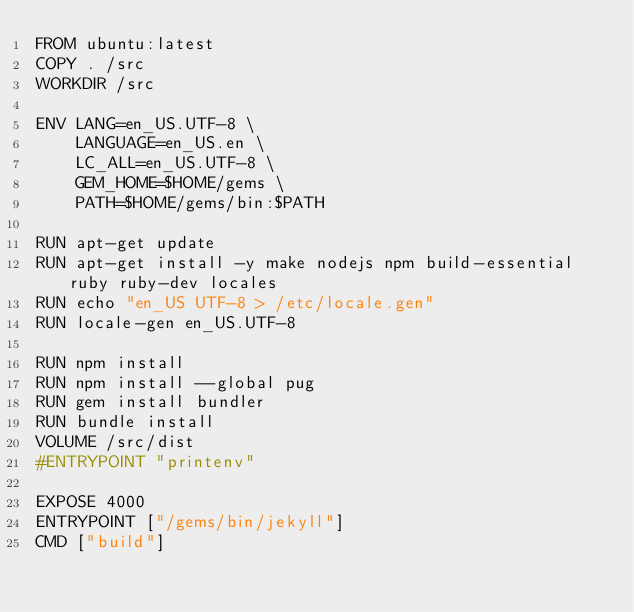Convert code to text. <code><loc_0><loc_0><loc_500><loc_500><_Dockerfile_>FROM ubuntu:latest
COPY . /src
WORKDIR /src

ENV LANG=en_US.UTF-8 \
    LANGUAGE=en_US.en \
    LC_ALL=en_US.UTF-8 \
    GEM_HOME=$HOME/gems \
    PATH=$HOME/gems/bin:$PATH

RUN apt-get update
RUN apt-get install -y make nodejs npm build-essential ruby ruby-dev locales
RUN echo "en_US UTF-8 > /etc/locale.gen"
RUN locale-gen en_US.UTF-8

RUN npm install 
RUN npm install --global pug
RUN gem install bundler
RUN bundle install
VOLUME /src/dist
#ENTRYPOINT "printenv"

EXPOSE 4000
ENTRYPOINT ["/gems/bin/jekyll"]
CMD ["build"]
</code> 